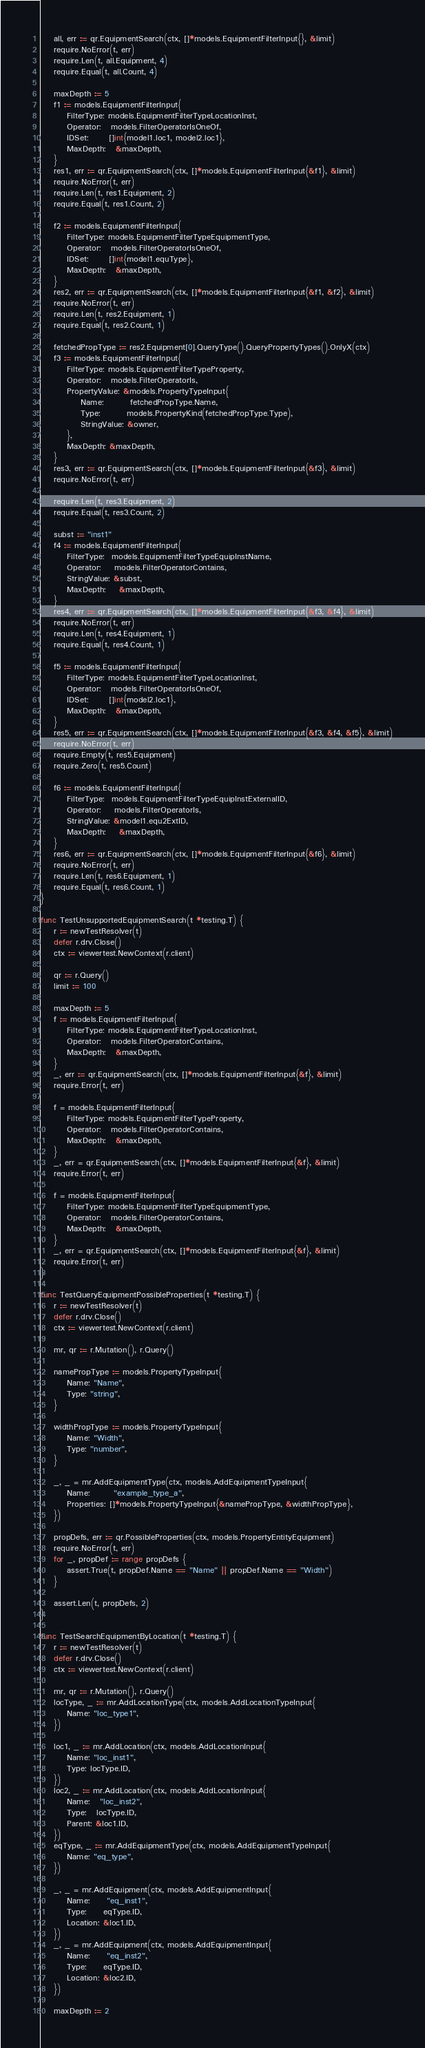Convert code to text. <code><loc_0><loc_0><loc_500><loc_500><_Go_>	all, err := qr.EquipmentSearch(ctx, []*models.EquipmentFilterInput{}, &limit)
	require.NoError(t, err)
	require.Len(t, all.Equipment, 4)
	require.Equal(t, all.Count, 4)

	maxDepth := 5
	f1 := models.EquipmentFilterInput{
		FilterType: models.EquipmentFilterTypeLocationInst,
		Operator:   models.FilterOperatorIsOneOf,
		IDSet:      []int{model1.loc1, model2.loc1},
		MaxDepth:   &maxDepth,
	}
	res1, err := qr.EquipmentSearch(ctx, []*models.EquipmentFilterInput{&f1}, &limit)
	require.NoError(t, err)
	require.Len(t, res1.Equipment, 2)
	require.Equal(t, res1.Count, 2)

	f2 := models.EquipmentFilterInput{
		FilterType: models.EquipmentFilterTypeEquipmentType,
		Operator:   models.FilterOperatorIsOneOf,
		IDSet:      []int{model1.equType},
		MaxDepth:   &maxDepth,
	}
	res2, err := qr.EquipmentSearch(ctx, []*models.EquipmentFilterInput{&f1, &f2}, &limit)
	require.NoError(t, err)
	require.Len(t, res2.Equipment, 1)
	require.Equal(t, res2.Count, 1)

	fetchedPropType := res2.Equipment[0].QueryType().QueryPropertyTypes().OnlyX(ctx)
	f3 := models.EquipmentFilterInput{
		FilterType: models.EquipmentFilterTypeProperty,
		Operator:   models.FilterOperatorIs,
		PropertyValue: &models.PropertyTypeInput{
			Name:        fetchedPropType.Name,
			Type:        models.PropertyKind(fetchedPropType.Type),
			StringValue: &owner,
		},
		MaxDepth: &maxDepth,
	}
	res3, err := qr.EquipmentSearch(ctx, []*models.EquipmentFilterInput{&f3}, &limit)
	require.NoError(t, err)

	require.Len(t, res3.Equipment, 2)
	require.Equal(t, res3.Count, 2)

	subst := "inst1"
	f4 := models.EquipmentFilterInput{
		FilterType:  models.EquipmentFilterTypeEquipInstName,
		Operator:    models.FilterOperatorContains,
		StringValue: &subst,
		MaxDepth:    &maxDepth,
	}
	res4, err := qr.EquipmentSearch(ctx, []*models.EquipmentFilterInput{&f3, &f4}, &limit)
	require.NoError(t, err)
	require.Len(t, res4.Equipment, 1)
	require.Equal(t, res4.Count, 1)

	f5 := models.EquipmentFilterInput{
		FilterType: models.EquipmentFilterTypeLocationInst,
		Operator:   models.FilterOperatorIsOneOf,
		IDSet:      []int{model2.loc1},
		MaxDepth:   &maxDepth,
	}
	res5, err := qr.EquipmentSearch(ctx, []*models.EquipmentFilterInput{&f3, &f4, &f5}, &limit)
	require.NoError(t, err)
	require.Empty(t, res5.Equipment)
	require.Zero(t, res5.Count)

	f6 := models.EquipmentFilterInput{
		FilterType:  models.EquipmentFilterTypeEquipInstExternalID,
		Operator:    models.FilterOperatorIs,
		StringValue: &model1.equ2ExtID,
		MaxDepth:    &maxDepth,
	}
	res6, err := qr.EquipmentSearch(ctx, []*models.EquipmentFilterInput{&f6}, &limit)
	require.NoError(t, err)
	require.Len(t, res6.Equipment, 1)
	require.Equal(t, res6.Count, 1)
}

func TestUnsupportedEquipmentSearch(t *testing.T) {
	r := newTestResolver(t)
	defer r.drv.Close()
	ctx := viewertest.NewContext(r.client)

	qr := r.Query()
	limit := 100

	maxDepth := 5
	f := models.EquipmentFilterInput{
		FilterType: models.EquipmentFilterTypeLocationInst,
		Operator:   models.FilterOperatorContains,
		MaxDepth:   &maxDepth,
	}
	_, err := qr.EquipmentSearch(ctx, []*models.EquipmentFilterInput{&f}, &limit)
	require.Error(t, err)

	f = models.EquipmentFilterInput{
		FilterType: models.EquipmentFilterTypeProperty,
		Operator:   models.FilterOperatorContains,
		MaxDepth:   &maxDepth,
	}
	_, err = qr.EquipmentSearch(ctx, []*models.EquipmentFilterInput{&f}, &limit)
	require.Error(t, err)

	f = models.EquipmentFilterInput{
		FilterType: models.EquipmentFilterTypeEquipmentType,
		Operator:   models.FilterOperatorContains,
		MaxDepth:   &maxDepth,
	}
	_, err = qr.EquipmentSearch(ctx, []*models.EquipmentFilterInput{&f}, &limit)
	require.Error(t, err)
}

func TestQueryEquipmentPossibleProperties(t *testing.T) {
	r := newTestResolver(t)
	defer r.drv.Close()
	ctx := viewertest.NewContext(r.client)

	mr, qr := r.Mutation(), r.Query()

	namePropType := models.PropertyTypeInput{
		Name: "Name",
		Type: "string",
	}

	widthPropType := models.PropertyTypeInput{
		Name: "Width",
		Type: "number",
	}

	_, _ = mr.AddEquipmentType(ctx, models.AddEquipmentTypeInput{
		Name:       "example_type_a",
		Properties: []*models.PropertyTypeInput{&namePropType, &widthPropType},
	})

	propDefs, err := qr.PossibleProperties(ctx, models.PropertyEntityEquipment)
	require.NoError(t, err)
	for _, propDef := range propDefs {
		assert.True(t, propDef.Name == "Name" || propDef.Name == "Width")
	}

	assert.Len(t, propDefs, 2)
}

func TestSearchEquipmentByLocation(t *testing.T) {
	r := newTestResolver(t)
	defer r.drv.Close()
	ctx := viewertest.NewContext(r.client)

	mr, qr := r.Mutation(), r.Query()
	locType, _ := mr.AddLocationType(ctx, models.AddLocationTypeInput{
		Name: "loc_type1",
	})

	loc1, _ := mr.AddLocation(ctx, models.AddLocationInput{
		Name: "loc_inst1",
		Type: locType.ID,
	})
	loc2, _ := mr.AddLocation(ctx, models.AddLocationInput{
		Name:   "loc_inst2",
		Type:   locType.ID,
		Parent: &loc1.ID,
	})
	eqType, _ := mr.AddEquipmentType(ctx, models.AddEquipmentTypeInput{
		Name: "eq_type",
	})

	_, _ = mr.AddEquipment(ctx, models.AddEquipmentInput{
		Name:     "eq_inst1",
		Type:     eqType.ID,
		Location: &loc1.ID,
	})
	_, _ = mr.AddEquipment(ctx, models.AddEquipmentInput{
		Name:     "eq_inst2",
		Type:     eqType.ID,
		Location: &loc2.ID,
	})

	maxDepth := 2</code> 